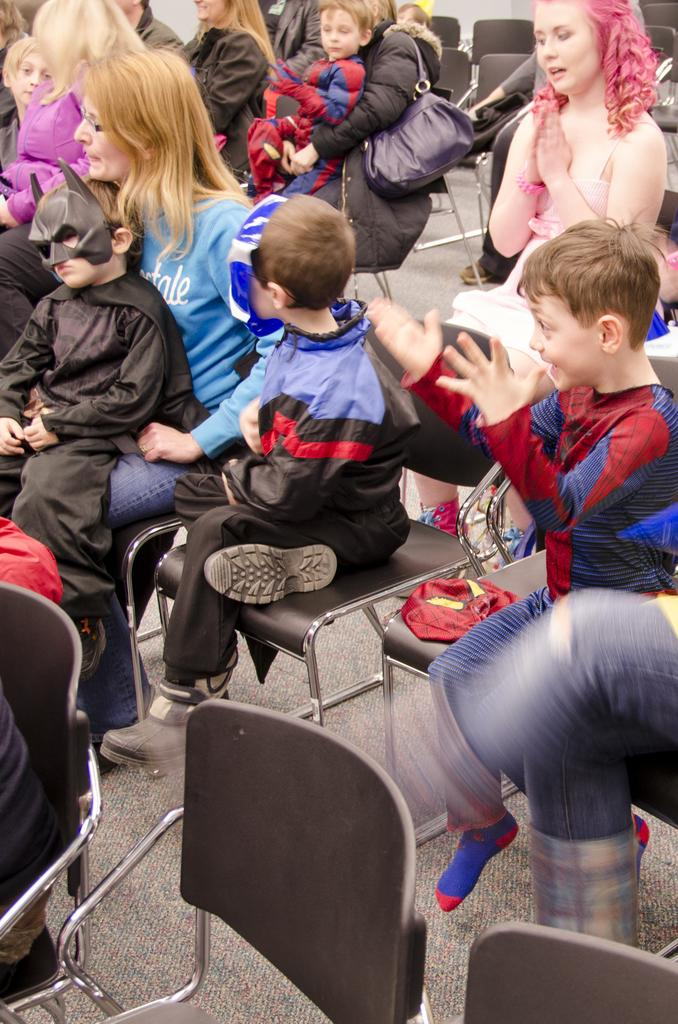What are the people in the image doing? The people in the image are sitting on chairs. Can you describe the children in the image? The children in the image are wearing costumes. What type of sheet is covering the railway in the image? There is: There is no sheet or railway present in the image. 